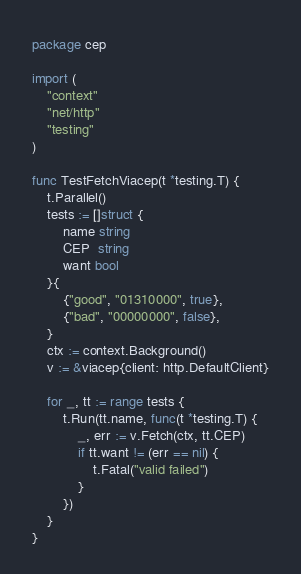Convert code to text. <code><loc_0><loc_0><loc_500><loc_500><_Go_>package cep

import (
	"context"
	"net/http"
	"testing"
)

func TestFetchViacep(t *testing.T) {
	t.Parallel()
	tests := []struct {
		name string
		CEP  string
		want bool
	}{
		{"good", "01310000", true},
		{"bad", "00000000", false},
	}
	ctx := context.Background()
	v := &viacep{client: http.DefaultClient}

	for _, tt := range tests {
		t.Run(tt.name, func(t *testing.T) {
			_, err := v.Fetch(ctx, tt.CEP)
			if tt.want != (err == nil) {
				t.Fatal("valid failed")
			}
		})
	}
}
</code> 